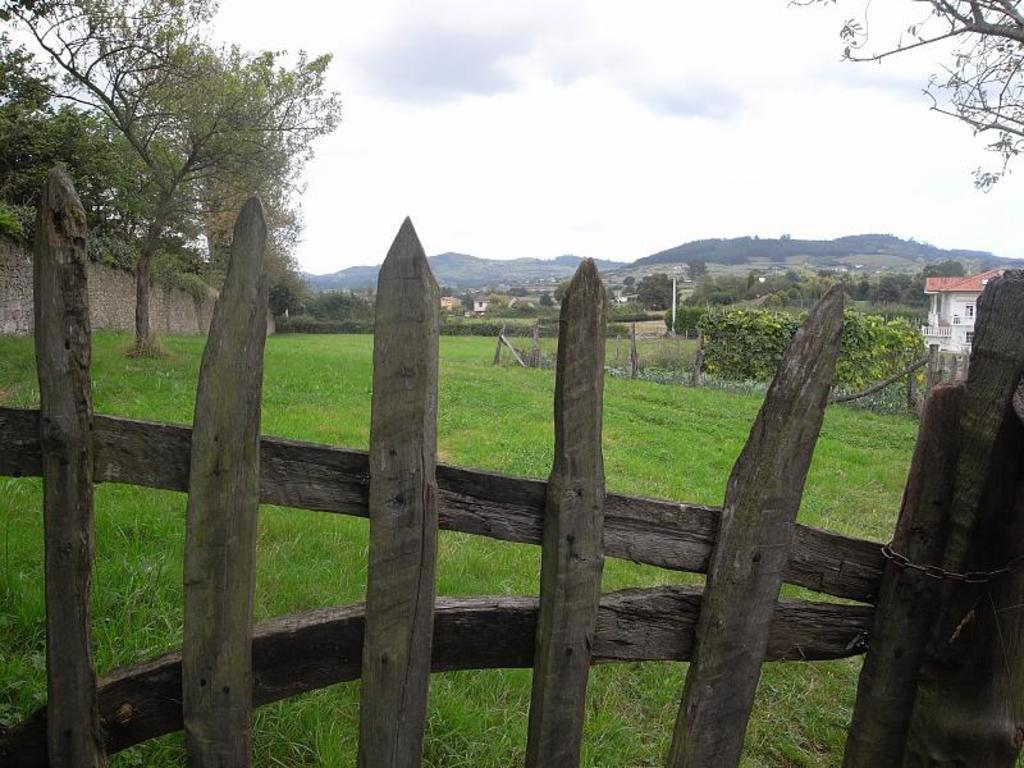What type of fence can be seen in the image? There is a wooden fence in the image. What type of vegetation is present in the image? There is grass in the image. What can be seen in the background of the image? There are trees, houses, hills, plants, a wall, and the sky visible in the background of the image. What type of stone is being gripped by the person in the image? There is no person present in the image, and therefore no stone or grip can be observed. 